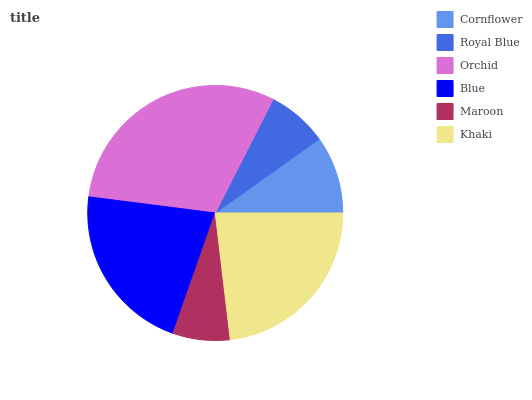Is Maroon the minimum?
Answer yes or no. Yes. Is Orchid the maximum?
Answer yes or no. Yes. Is Royal Blue the minimum?
Answer yes or no. No. Is Royal Blue the maximum?
Answer yes or no. No. Is Cornflower greater than Royal Blue?
Answer yes or no. Yes. Is Royal Blue less than Cornflower?
Answer yes or no. Yes. Is Royal Blue greater than Cornflower?
Answer yes or no. No. Is Cornflower less than Royal Blue?
Answer yes or no. No. Is Blue the high median?
Answer yes or no. Yes. Is Cornflower the low median?
Answer yes or no. Yes. Is Cornflower the high median?
Answer yes or no. No. Is Blue the low median?
Answer yes or no. No. 